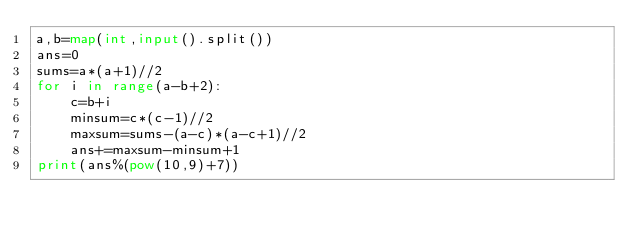<code> <loc_0><loc_0><loc_500><loc_500><_Python_>a,b=map(int,input().split())
ans=0
sums=a*(a+1)//2
for i in range(a-b+2):
    c=b+i
    minsum=c*(c-1)//2
    maxsum=sums-(a-c)*(a-c+1)//2
    ans+=maxsum-minsum+1
print(ans%(pow(10,9)+7))</code> 